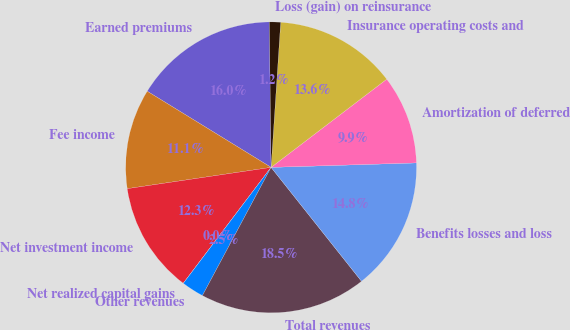Convert chart. <chart><loc_0><loc_0><loc_500><loc_500><pie_chart><fcel>Earned premiums<fcel>Fee income<fcel>Net investment income<fcel>Net realized capital gains<fcel>Other revenues<fcel>Total revenues<fcel>Benefits losses and loss<fcel>Amortization of deferred<fcel>Insurance operating costs and<fcel>Loss (gain) on reinsurance<nl><fcel>16.04%<fcel>11.11%<fcel>12.34%<fcel>0.01%<fcel>2.48%<fcel>18.51%<fcel>14.81%<fcel>9.88%<fcel>13.58%<fcel>1.24%<nl></chart> 